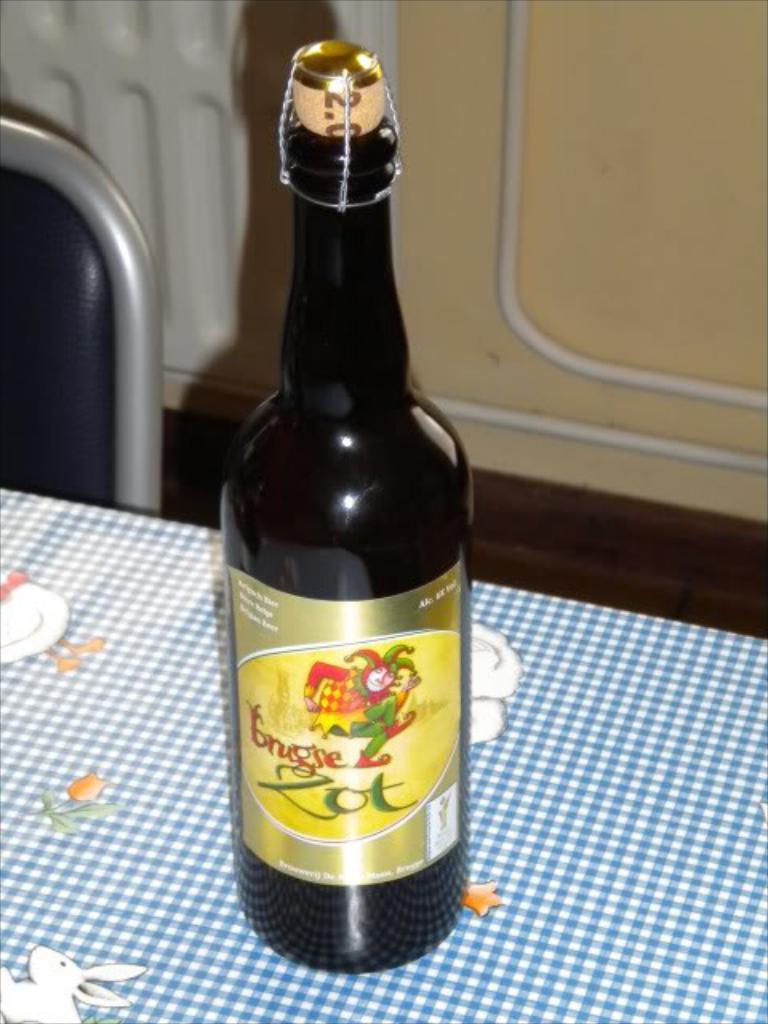How would you summarize this image in a sentence or two? In this image I can see a bottle kept on table , on the table I can see a cloth , in front of table it might be a chair on the left side 